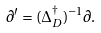Convert formula to latex. <formula><loc_0><loc_0><loc_500><loc_500>\partial ^ { \prime } = ( \Delta _ { D } ^ { \dag } ) ^ { - 1 } \partial .</formula> 